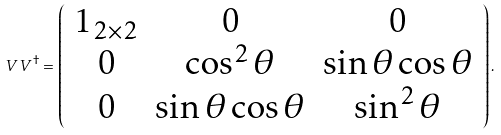<formula> <loc_0><loc_0><loc_500><loc_500>V V ^ { \dag } = \left ( \begin{array} { c c c } 1 _ { 2 \times 2 } & 0 & 0 \\ 0 & \cos ^ { 2 } \theta & \sin \theta \cos \theta \\ 0 & \sin \theta \cos \theta & \sin ^ { 2 } \theta \\ \end{array} \right ) .</formula> 